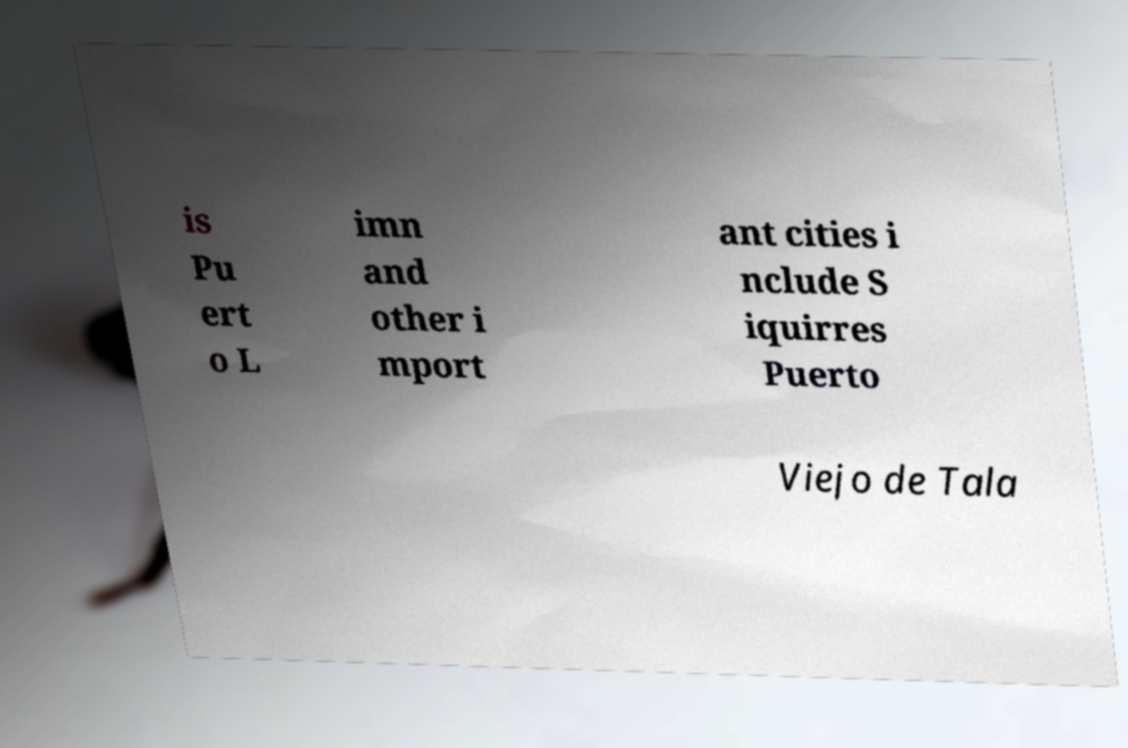For documentation purposes, I need the text within this image transcribed. Could you provide that? is Pu ert o L imn and other i mport ant cities i nclude S iquirres Puerto Viejo de Tala 